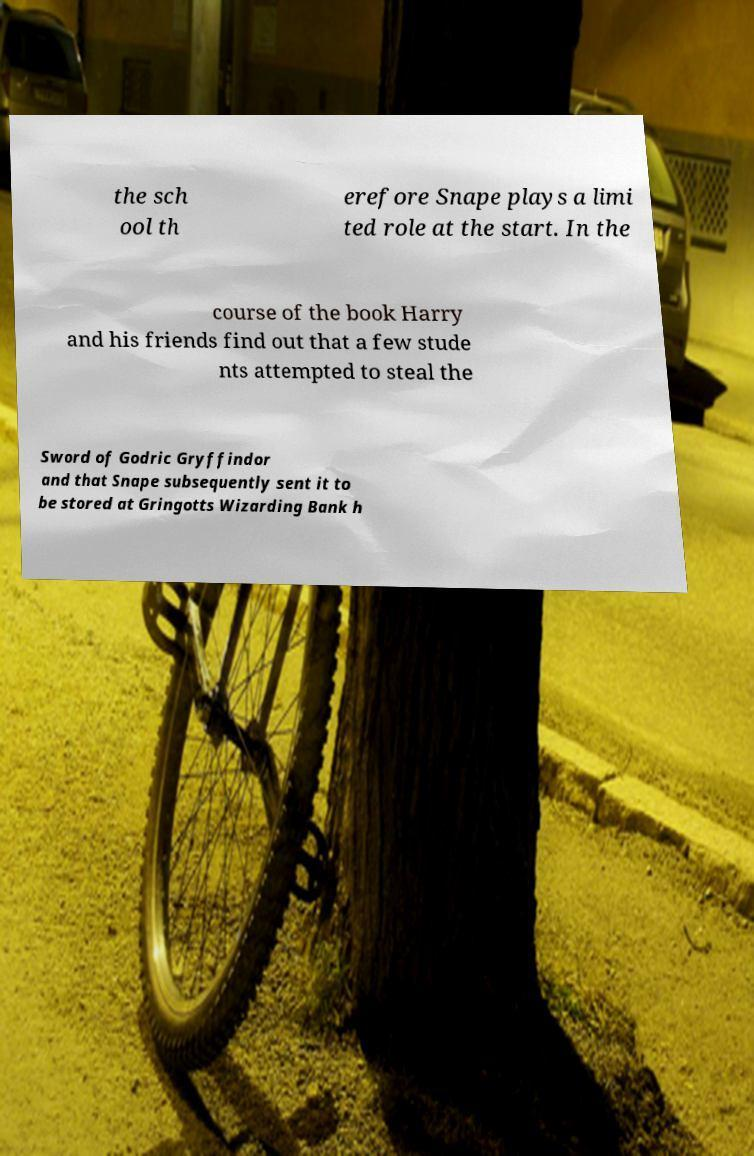Could you extract and type out the text from this image? the sch ool th erefore Snape plays a limi ted role at the start. In the course of the book Harry and his friends find out that a few stude nts attempted to steal the Sword of Godric Gryffindor and that Snape subsequently sent it to be stored at Gringotts Wizarding Bank h 